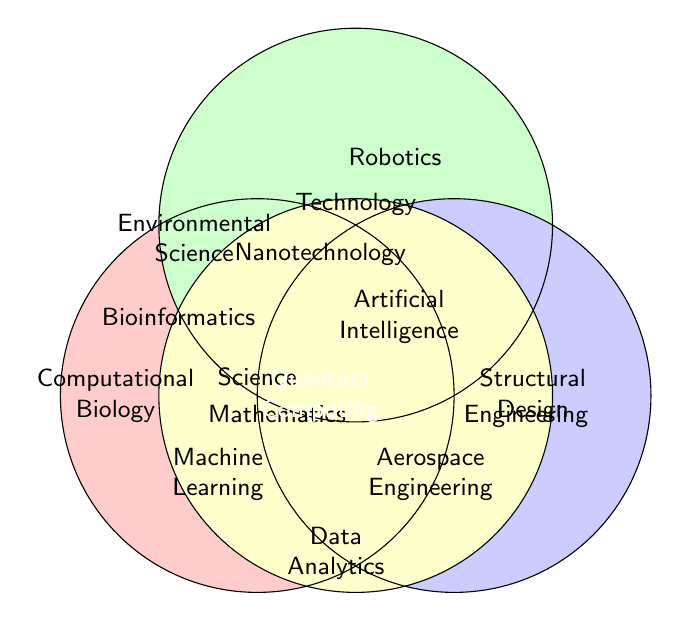What fields are unique to Science in the diagram? Only Computational Biology and Environmental Science are positioned in the exclusive Science area without overlapping with other categories.
Answer: Computational Biology, Environmental Science Which fields are common to both Science and Technology? The intersecting section between Science and Technology contains Bioinformatics, Nanotechnology, Machine Learning, Quantum Computing, and Environmental Science.
Answer: Bioinformatics, Nanotechnology, Machine Learning, Quantum Computing, Environmental Science What category does Engineering and Mathematics share? The overlapping region between Engineering and Mathematics includes Aerospace Engineering and Quantum Computing.
Answer: Aerospace Engineering, Quantum Computing Name all fields that intersect with Mathematics. The fields in the intersections including Mathematics are Data Analytics, Aerospace Engineering, Quantum Computing, Machine Learning, Artificial Intelligence, and Nanotechnology.
Answer: Data Analytics, Aerospace Engineering, Quantum Computing, Machine Learning, Artificial Intelligence, Nanotechnology Which category is only connected with Quantum Computing? Quantum Computing is within the intersection of all categories: Science, Technology, Engineering, and Mathematics. Therefore, it connects all four.
Answer: Science, Technology, Engineering, Mathematics What fields are situated in the intersection of Engineering and Technology? The fields found in the overlapping space between Engineering and Technology are Nanotechnology and Machine Learning.
Answer: Nanotechnology, Machine Learning 